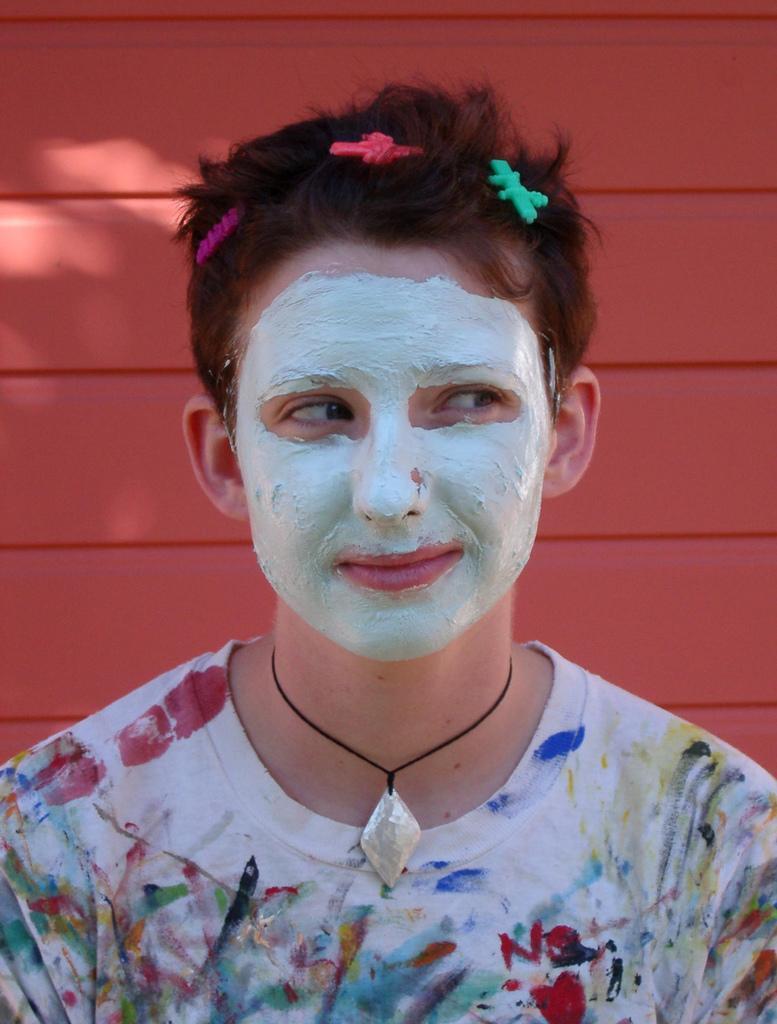In one or two sentences, can you explain what this image depicts? In this image we can see a person wearing dress and hair clips. In the background, we can see the wall. 